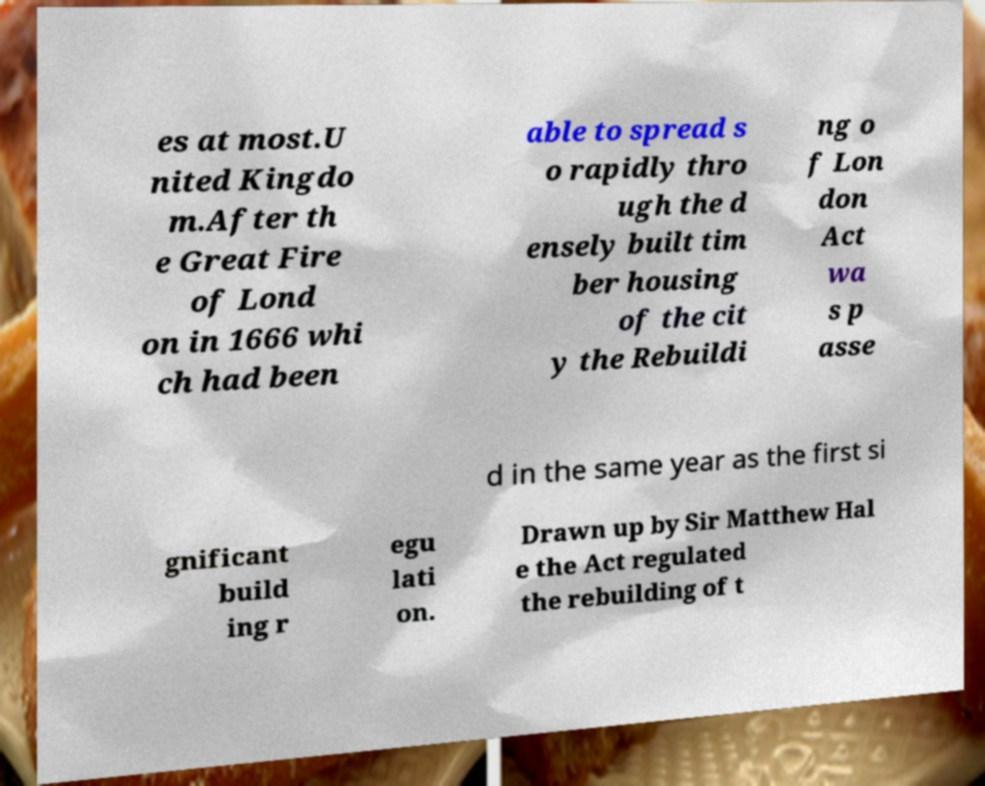Could you extract and type out the text from this image? es at most.U nited Kingdo m.After th e Great Fire of Lond on in 1666 whi ch had been able to spread s o rapidly thro ugh the d ensely built tim ber housing of the cit y the Rebuildi ng o f Lon don Act wa s p asse d in the same year as the first si gnificant build ing r egu lati on. Drawn up by Sir Matthew Hal e the Act regulated the rebuilding of t 